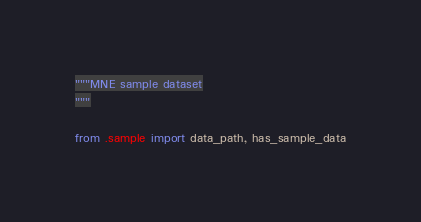<code> <loc_0><loc_0><loc_500><loc_500><_Python_>"""MNE sample dataset
"""

from .sample import data_path, has_sample_data
</code> 